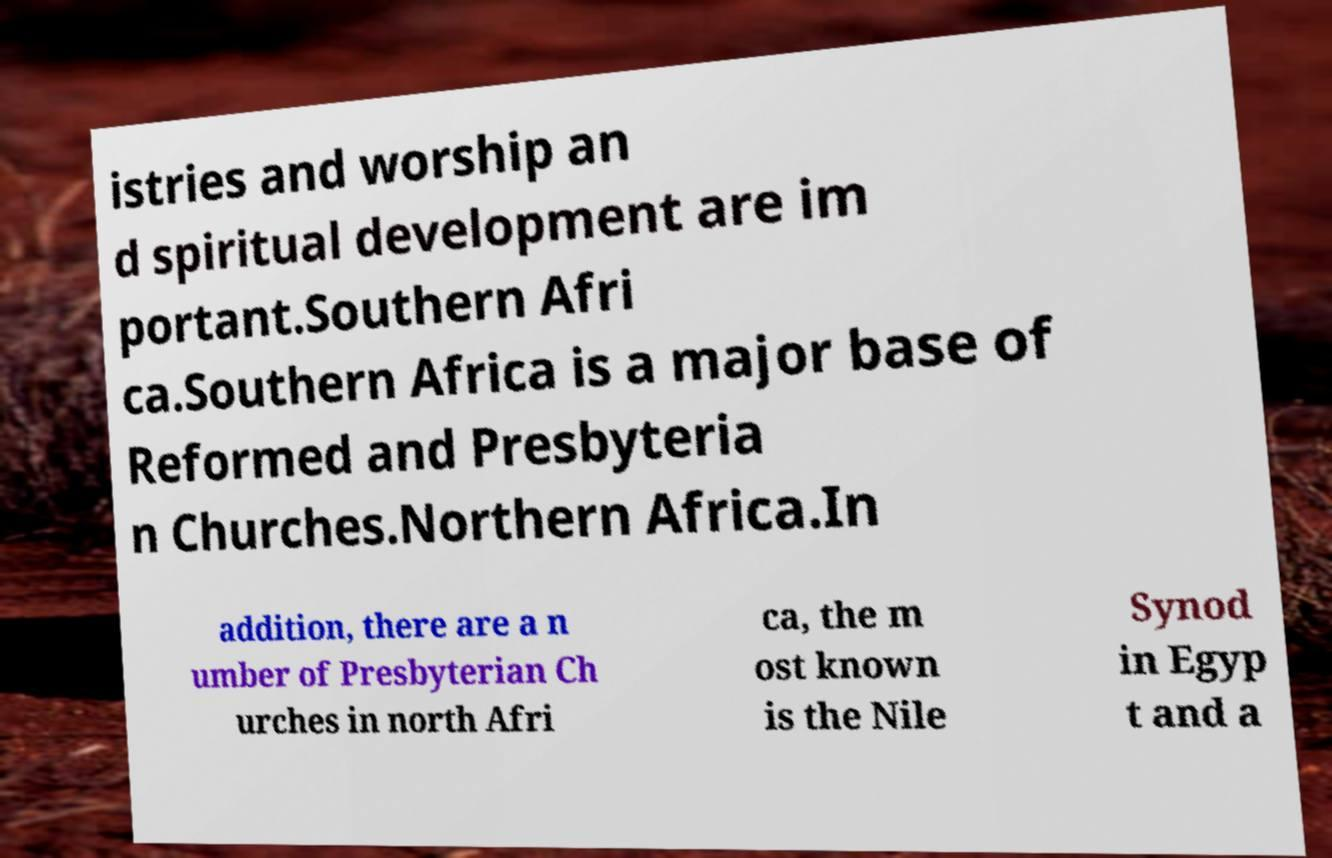Can you read and provide the text displayed in the image?This photo seems to have some interesting text. Can you extract and type it out for me? istries and worship an d spiritual development are im portant.Southern Afri ca.Southern Africa is a major base of Reformed and Presbyteria n Churches.Northern Africa.In addition, there are a n umber of Presbyterian Ch urches in north Afri ca, the m ost known is the Nile Synod in Egyp t and a 